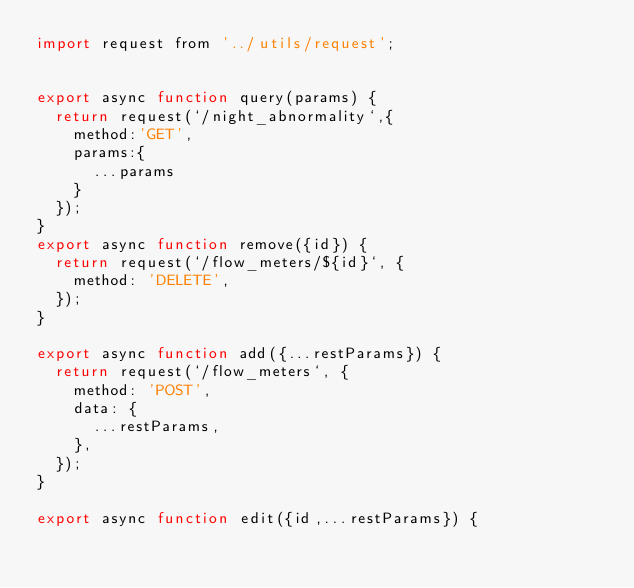Convert code to text. <code><loc_0><loc_0><loc_500><loc_500><_JavaScript_>import request from '../utils/request';


export async function query(params) {
  return request(`/night_abnormality`,{
    method:'GET',
    params:{
      ...params
    }
  });
}
export async function remove({id}) {
  return request(`/flow_meters/${id}`, {
    method: 'DELETE',
  });
}

export async function add({...restParams}) {
  return request(`/flow_meters`, {
    method: 'POST',
    data: {
      ...restParams,
    },
  });
}

export async function edit({id,...restParams}) {</code> 